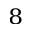<formula> <loc_0><loc_0><loc_500><loc_500>_ { 8 }</formula> 